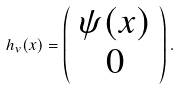Convert formula to latex. <formula><loc_0><loc_0><loc_500><loc_500>h _ { v } ( x ) = \left ( \begin{array} { c } \psi ( x ) \\ 0 \end{array} \right ) .</formula> 